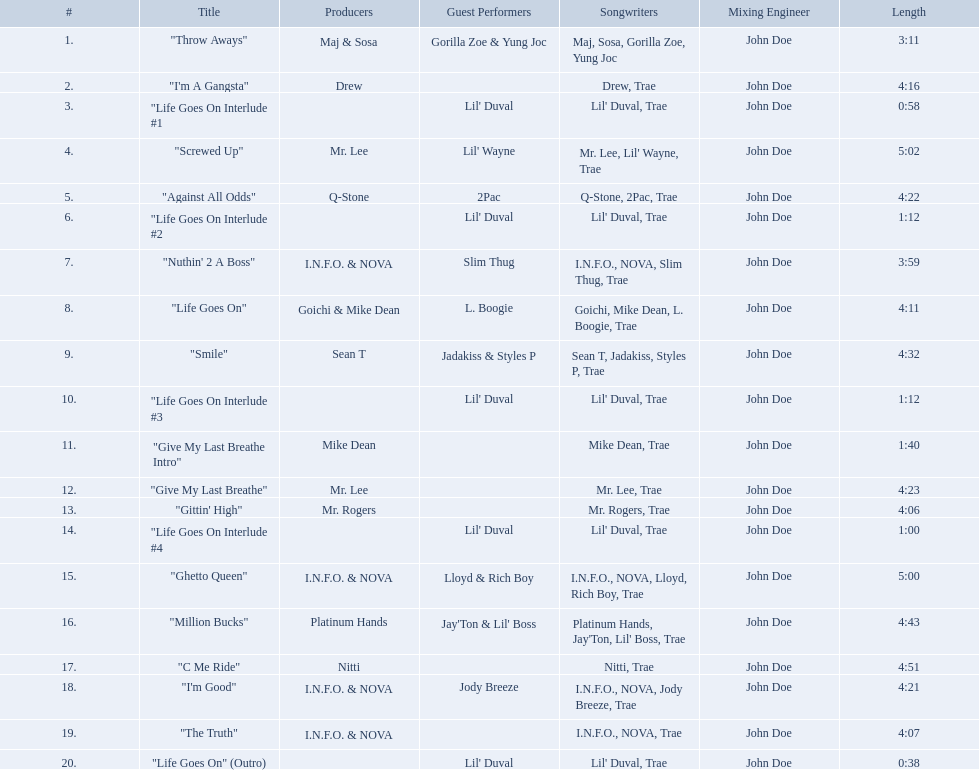Which tracks are longer than 4.00? "I'm A Gangsta", "Screwed Up", "Against All Odds", "Life Goes On", "Smile", "Give My Last Breathe", "Gittin' High", "Ghetto Queen", "Million Bucks", "C Me Ride", "I'm Good", "The Truth". Of those, which tracks are longer than 4.30? "Screwed Up", "Smile", "Ghetto Queen", "Million Bucks", "C Me Ride". Of those, which tracks are 5.00 or longer? "Screwed Up", "Ghetto Queen". Of those, which one is the longest? "Screwed Up". How long is that track? 5:02. 